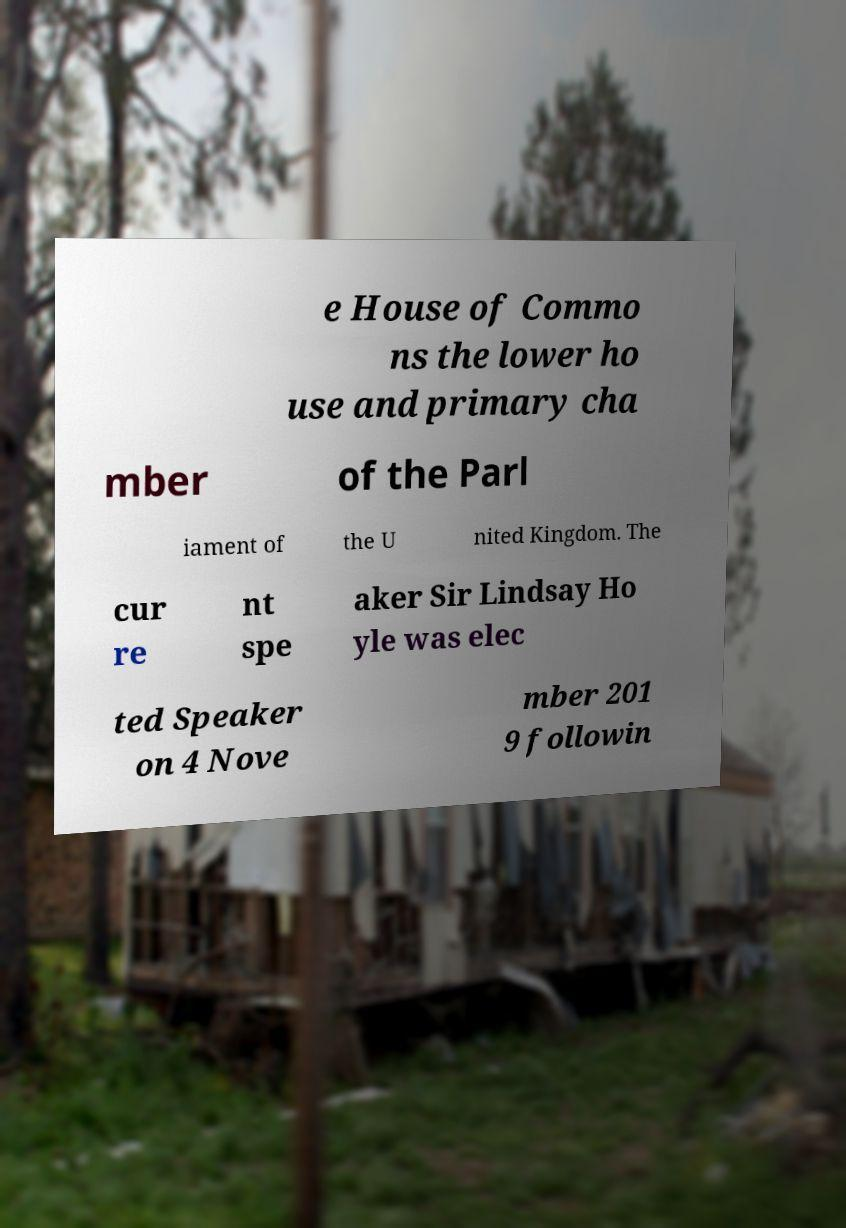What messages or text are displayed in this image? I need them in a readable, typed format. e House of Commo ns the lower ho use and primary cha mber of the Parl iament of the U nited Kingdom. The cur re nt spe aker Sir Lindsay Ho yle was elec ted Speaker on 4 Nove mber 201 9 followin 